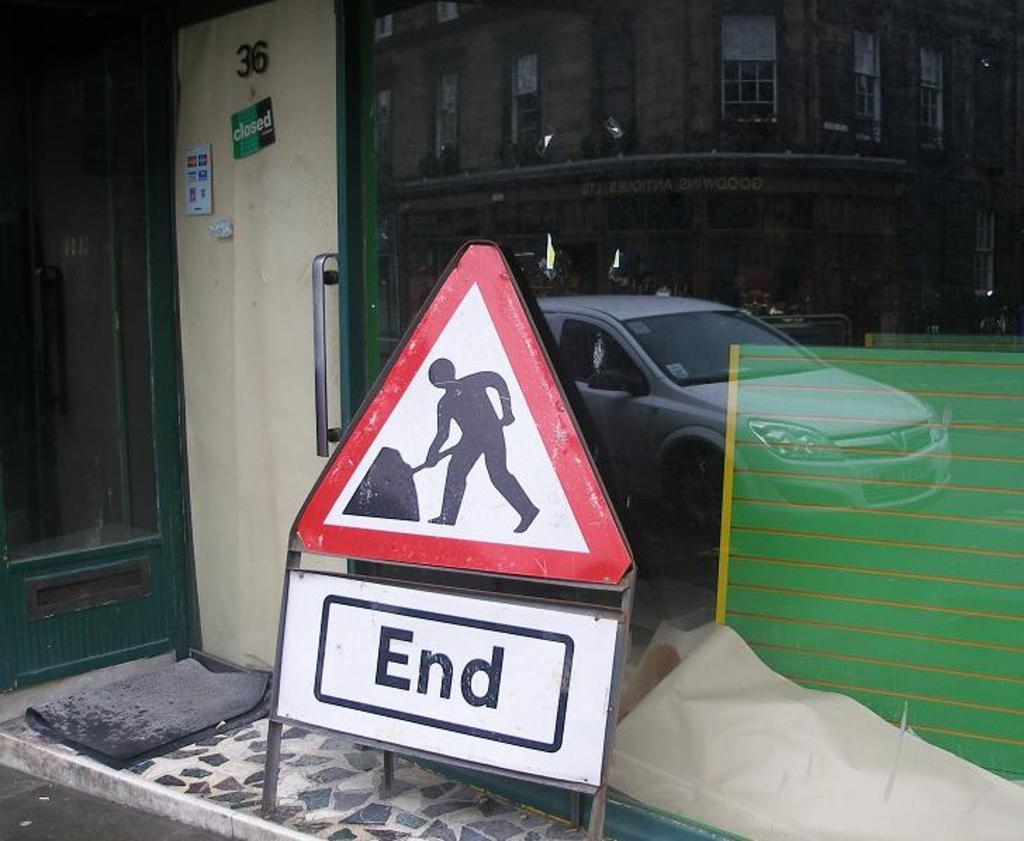<image>
Describe the image concisely. a yield sign has a man digging and the word END 